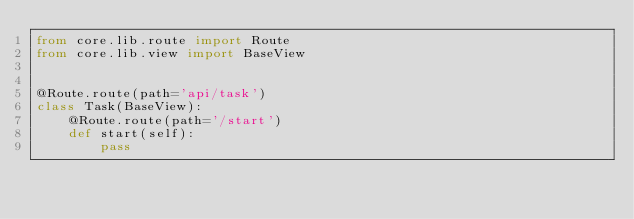<code> <loc_0><loc_0><loc_500><loc_500><_Python_>from core.lib.route import Route
from core.lib.view import BaseView


@Route.route(path='api/task')
class Task(BaseView):
    @Route.route(path='/start')
    def start(self):
        pass
</code> 